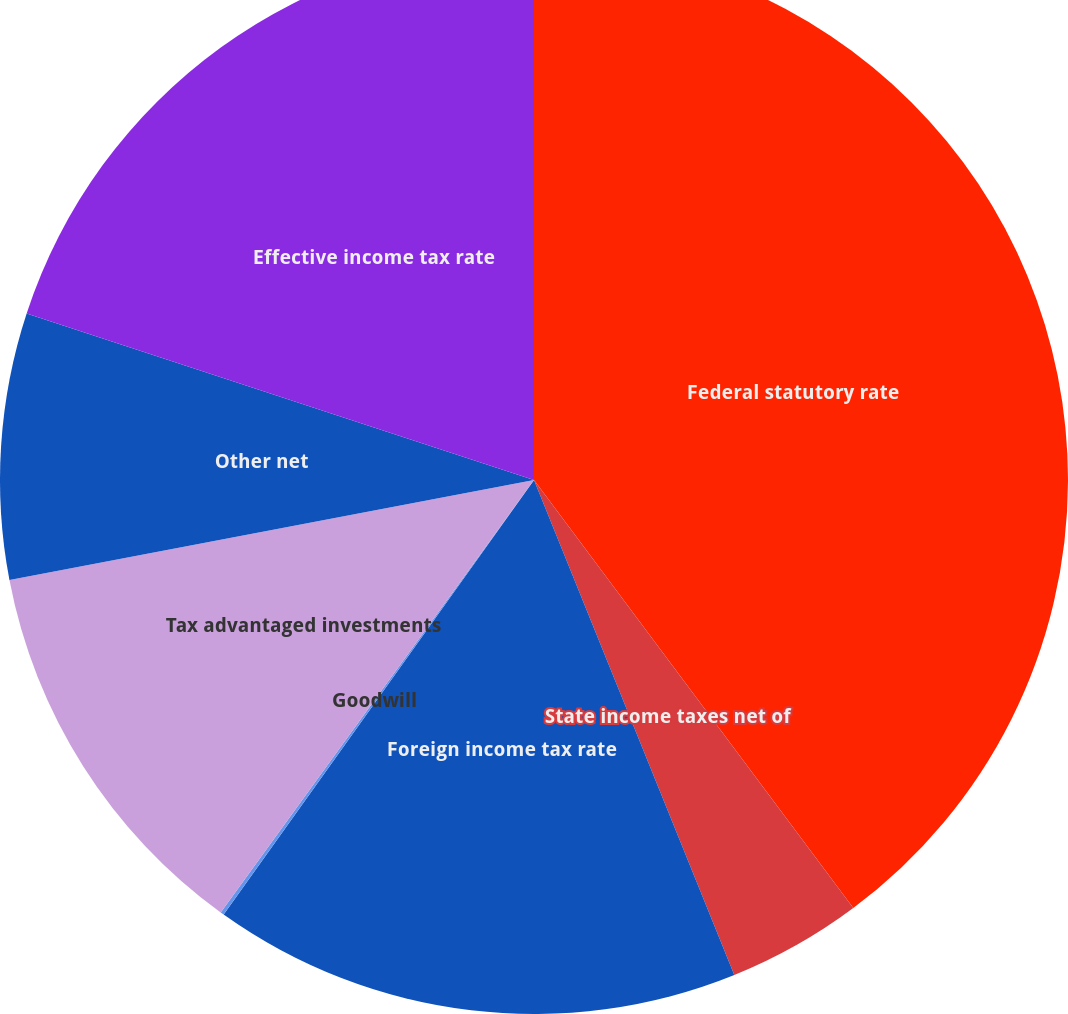Convert chart. <chart><loc_0><loc_0><loc_500><loc_500><pie_chart><fcel>Federal statutory rate<fcel>State income taxes net of<fcel>Foreign income tax rate<fcel>Goodwill<fcel>Tax advantaged investments<fcel>Other net<fcel>Effective income tax rate<nl><fcel>39.8%<fcel>4.08%<fcel>15.99%<fcel>0.11%<fcel>12.02%<fcel>8.05%<fcel>19.95%<nl></chart> 